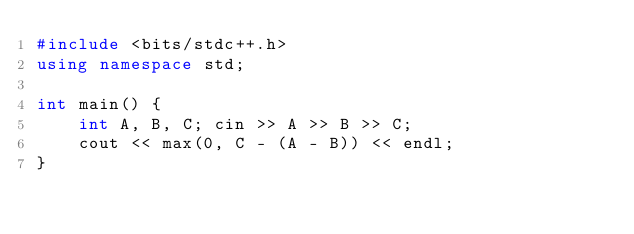Convert code to text. <code><loc_0><loc_0><loc_500><loc_500><_C++_>#include <bits/stdc++.h>
using namespace std;

int main() {
    int A, B, C; cin >> A >> B >> C;
    cout << max(0, C - (A - B)) << endl;
}
</code> 